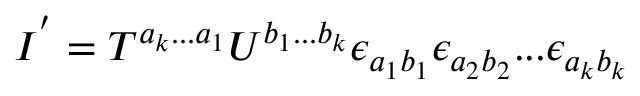<formula> <loc_0><loc_0><loc_500><loc_500>I ^ { ^ { \prime } } = T ^ { a _ { k } \dots a _ { 1 } } U ^ { b _ { 1 } \dots b _ { k } } \epsilon _ { a _ { 1 } b _ { 1 } } \epsilon _ { a _ { 2 } b _ { 2 } } \dots \epsilon _ { a _ { k } b _ { k } }</formula> 